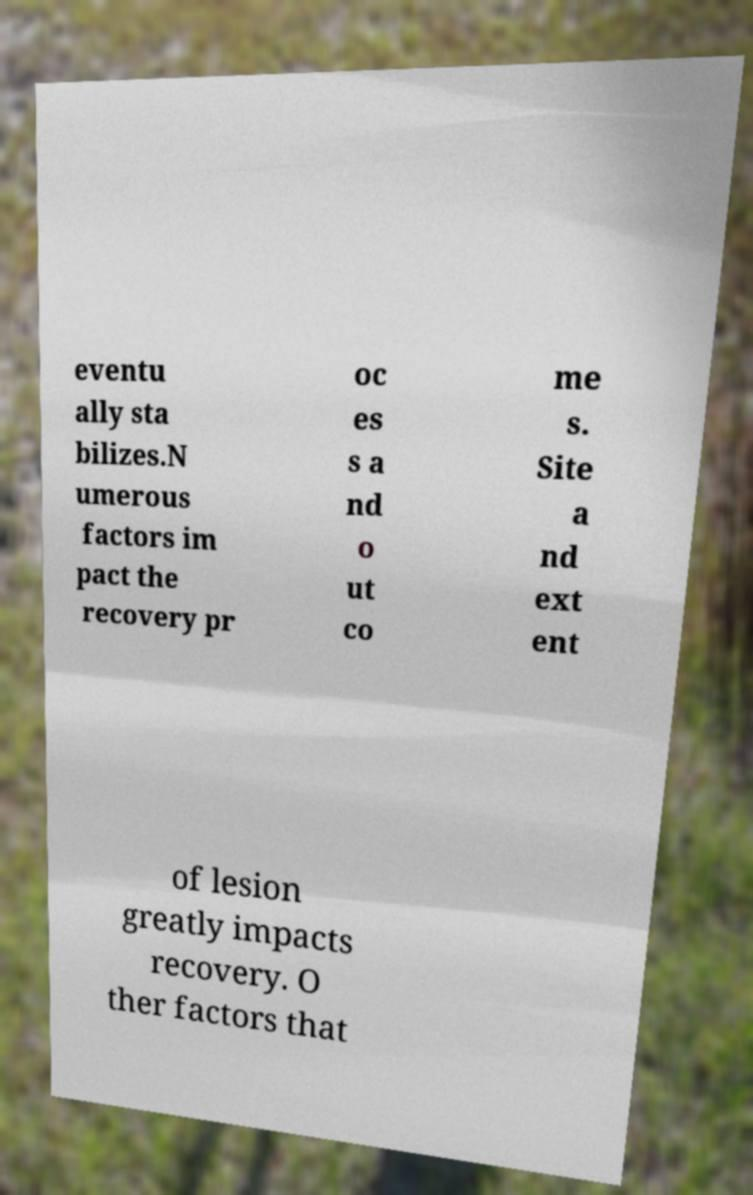I need the written content from this picture converted into text. Can you do that? eventu ally sta bilizes.N umerous factors im pact the recovery pr oc es s a nd o ut co me s. Site a nd ext ent of lesion greatly impacts recovery. O ther factors that 